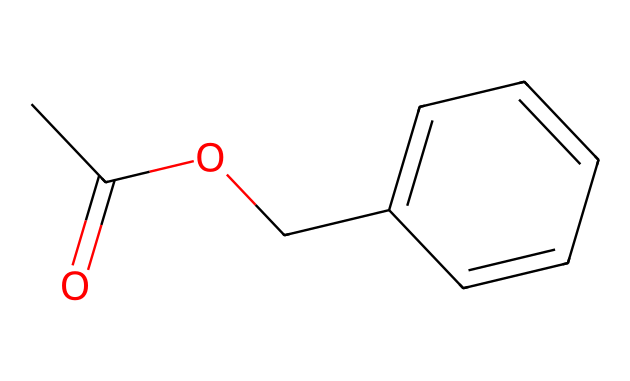What is the molecular formula of this compound? By analyzing the SMILES representation, we can identify the elements and their respective counts. The SMILES contains two carbons in the acetyl group (CC), with the additional carbon attached in the form of a phenyl ring (c1ccccc1), totaling nine carbons (C9). It also shows two hydrogens attached to each carbon in the acyl group and three more hydrogens in the aromatic ring, giving a total of ten hydrogens (H10), and two oxygens from the acetyl and methoxy (O2). Therefore, the molecular formula is C9H10O2.
Answer: C9H10O2 How many rings are present in the structure? The SMILES indicates a cyclic structure represented by "c1ccccc1". This notation denotes a benzene ring, which is a cycle of six carbon atoms. There are no other cyclic structures present in the SMILES. Hence, there is one ring in the compound.
Answer: 1 What type of functional groups are present in this chemical? Examining the structure derived from the SMILES reveals two functional groups: an ester group (from -O- and =O in the acetyl moiety) and a phenolic ring (due to the aromatic system present in the benzene structure). Thus, the compound exhibits both ester and aromatic functional groups.
Answer: ester and aromatic Why does this compound have a jasmine aroma? The characteristic jasmine aroma is attributed to the presence of benzyl acetate, which is an ester known for its sweet, floral fragrance. The combination of its ethyl acetate component with the aromatic benzene ring enhances its floral scent profile, thus making it suitable for perfumes, especially jasmine.
Answer: sweet, floral fragrance What is the significance of the acetate part in this compound? The acetate moiety, represented in the SMILES as CC(=O)O, contributes to the compound's volatility and pleasant odor. Esters like benzyl acetate are particularly known for their use in flavoring and fragrance applications because of their fruity and floral notes. Therefore, the acetate part is significant for its role in the fragrance profile.
Answer: pleasant odor How many double bonds are present in the chemical structure? Analyzing the SMILES representation shows there is one double bond in the acetyl portion (between carbon and oxygen, CC(=O)) and one between carbon atoms in the phenolic ring (part of c1ccccc1). Therefore, there are a total of two double bonds in the structure.
Answer: 2 